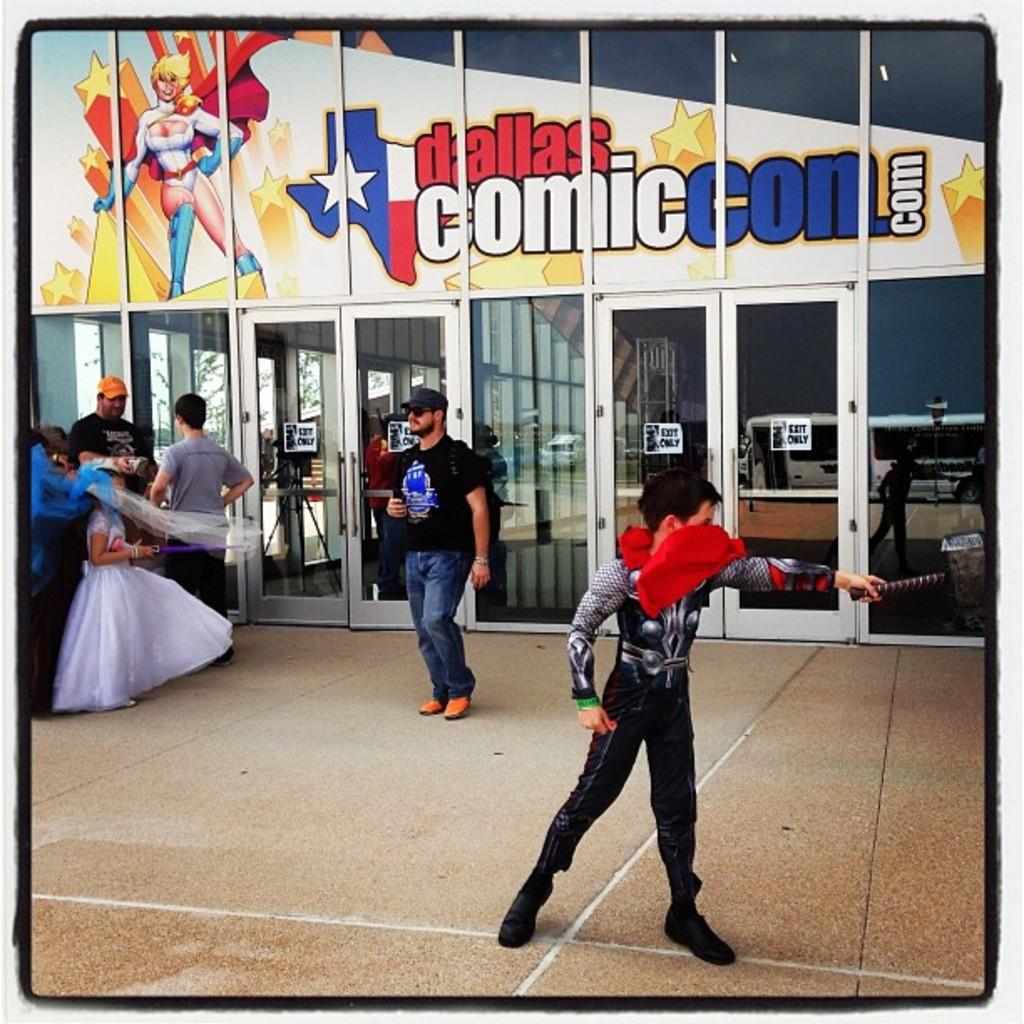What is happening in the image? There are people standing in the image. Can you describe the boy's attire? The boy is wearing a superhero costume. Where is the boy positioned in the image? The boy is on the right side of the image. What can be seen in the background of the image? There are glass doors in the background of the image. What type of chalk is the boy using to teach in the image? There is no chalk or teaching activity present in the image. How is the spoon being used by the people in the image? There is no spoon present in the image. 